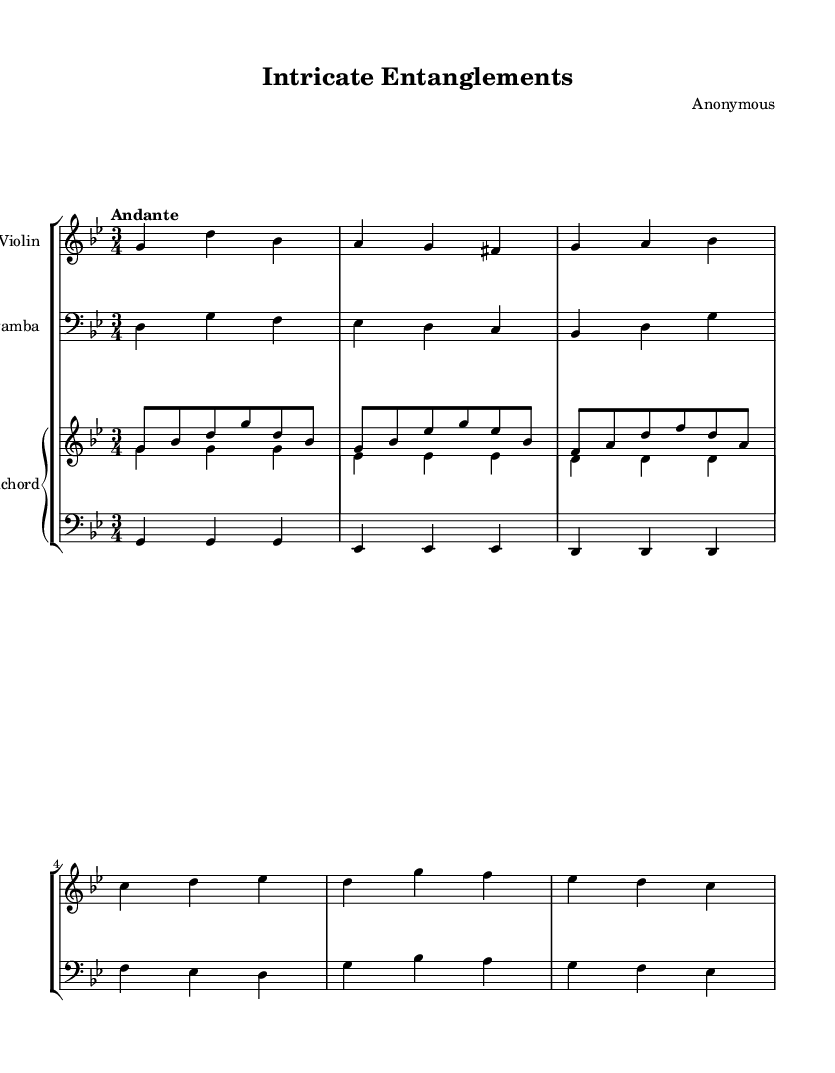What is the key signature of this music? The key signature is G minor, which includes the B flat. This can be identified by looking at the key signature indicators at the beginning of the staff.
Answer: G minor What is the time signature of the piece? The time signature is 3/4, which is indicated at the beginning of the score. This means there are three beats in each measure, and the quarter note gets one beat.
Answer: 3/4 What is the tempo marking for this music? The tempo marking is "Andante," which is noted above the score. This indicates a moderately slow tempo, typically around 76-108 beats per minute.
Answer: Andante How many instruments are in the score? There are four instruments in the score: Violin, Viola da gamba, and two staves for Harpsichord (right and left). Each instrument's staff is listed in the StaffGroup.
Answer: Four In which section does the Harpsichord's right hand play a G note? The Harpsichord's right hand plays a G note in the first measure, first beat. It is written in the treble clef, and you can find the G on that pitch in the measure.
Answer: First measure Which instrument plays the lowest pitch in the piece? The instrument that plays the lowest pitch is the Viola da gamba since it is in the bass clef and generally plays lower register notes compared to the other instruments.
Answer: Viola da gamba What musical form does this piece suggest based on the instrumentation? This piece suggests a chamber music form, as it includes a small ensemble of different instruments (strings and keyboard), typical of Baroque compositions.
Answer: Chamber music 